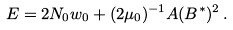Convert formula to latex. <formula><loc_0><loc_0><loc_500><loc_500>E = 2 N _ { 0 } w _ { 0 } + ( 2 \mu _ { 0 } ) ^ { - 1 } A ( B ^ { * } ) ^ { 2 } \, .</formula> 